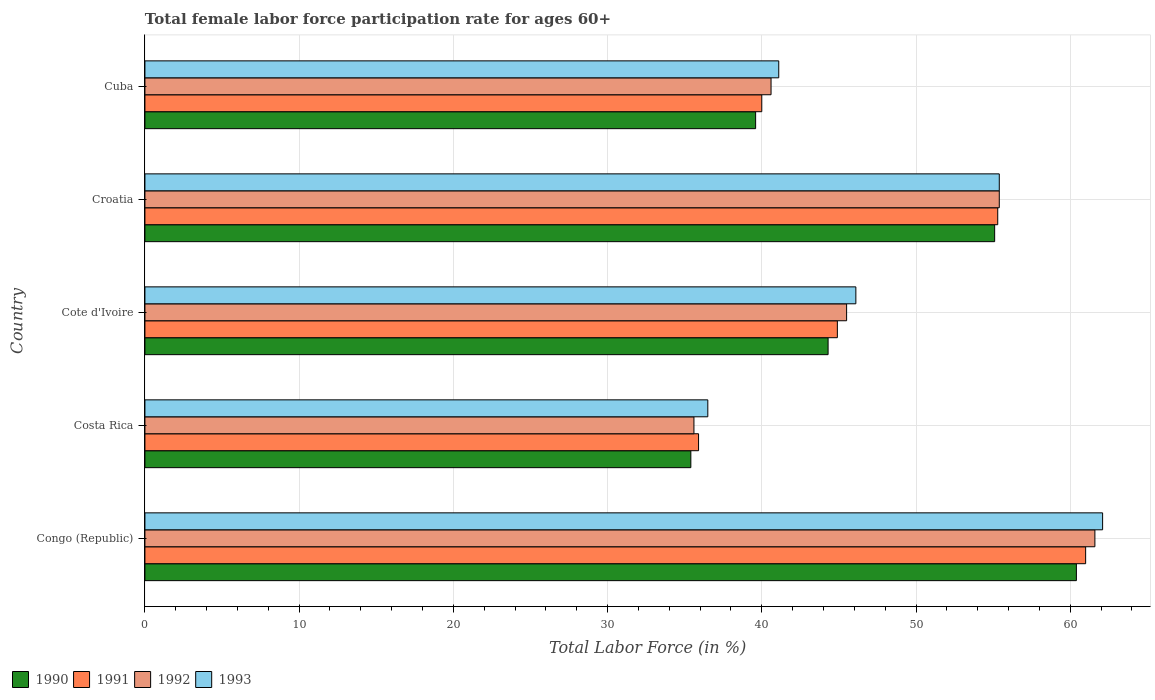How many different coloured bars are there?
Provide a succinct answer. 4. How many bars are there on the 5th tick from the bottom?
Ensure brevity in your answer.  4. What is the label of the 3rd group of bars from the top?
Make the answer very short. Cote d'Ivoire. In how many cases, is the number of bars for a given country not equal to the number of legend labels?
Make the answer very short. 0. What is the female labor force participation rate in 1993 in Croatia?
Provide a short and direct response. 55.4. Across all countries, what is the maximum female labor force participation rate in 1992?
Make the answer very short. 61.6. Across all countries, what is the minimum female labor force participation rate in 1990?
Keep it short and to the point. 35.4. In which country was the female labor force participation rate in 1993 maximum?
Make the answer very short. Congo (Republic). In which country was the female labor force participation rate in 1990 minimum?
Provide a short and direct response. Costa Rica. What is the total female labor force participation rate in 1990 in the graph?
Your response must be concise. 234.8. What is the difference between the female labor force participation rate in 1993 in Cote d'Ivoire and that in Cuba?
Give a very brief answer. 5. What is the difference between the female labor force participation rate in 1991 in Croatia and the female labor force participation rate in 1990 in Congo (Republic)?
Keep it short and to the point. -5.1. What is the average female labor force participation rate in 1990 per country?
Keep it short and to the point. 46.96. What is the difference between the female labor force participation rate in 1991 and female labor force participation rate in 1992 in Costa Rica?
Provide a short and direct response. 0.3. In how many countries, is the female labor force participation rate in 1991 greater than 8 %?
Give a very brief answer. 5. What is the ratio of the female labor force participation rate in 1993 in Congo (Republic) to that in Cuba?
Keep it short and to the point. 1.51. What is the difference between the highest and the second highest female labor force participation rate in 1993?
Keep it short and to the point. 6.7. In how many countries, is the female labor force participation rate in 1992 greater than the average female labor force participation rate in 1992 taken over all countries?
Provide a succinct answer. 2. Is the sum of the female labor force participation rate in 1991 in Croatia and Cuba greater than the maximum female labor force participation rate in 1993 across all countries?
Offer a very short reply. Yes. What does the 1st bar from the top in Costa Rica represents?
Make the answer very short. 1993. Is it the case that in every country, the sum of the female labor force participation rate in 1993 and female labor force participation rate in 1991 is greater than the female labor force participation rate in 1990?
Keep it short and to the point. Yes. How many countries are there in the graph?
Ensure brevity in your answer.  5. Does the graph contain any zero values?
Your answer should be very brief. No. Does the graph contain grids?
Offer a terse response. Yes. Where does the legend appear in the graph?
Give a very brief answer. Bottom left. How many legend labels are there?
Provide a short and direct response. 4. How are the legend labels stacked?
Provide a succinct answer. Horizontal. What is the title of the graph?
Provide a succinct answer. Total female labor force participation rate for ages 60+. Does "1979" appear as one of the legend labels in the graph?
Give a very brief answer. No. What is the label or title of the X-axis?
Provide a short and direct response. Total Labor Force (in %). What is the Total Labor Force (in %) of 1990 in Congo (Republic)?
Make the answer very short. 60.4. What is the Total Labor Force (in %) in 1992 in Congo (Republic)?
Offer a very short reply. 61.6. What is the Total Labor Force (in %) in 1993 in Congo (Republic)?
Ensure brevity in your answer.  62.1. What is the Total Labor Force (in %) of 1990 in Costa Rica?
Offer a very short reply. 35.4. What is the Total Labor Force (in %) of 1991 in Costa Rica?
Give a very brief answer. 35.9. What is the Total Labor Force (in %) of 1992 in Costa Rica?
Your answer should be very brief. 35.6. What is the Total Labor Force (in %) of 1993 in Costa Rica?
Keep it short and to the point. 36.5. What is the Total Labor Force (in %) in 1990 in Cote d'Ivoire?
Make the answer very short. 44.3. What is the Total Labor Force (in %) in 1991 in Cote d'Ivoire?
Ensure brevity in your answer.  44.9. What is the Total Labor Force (in %) in 1992 in Cote d'Ivoire?
Offer a very short reply. 45.5. What is the Total Labor Force (in %) in 1993 in Cote d'Ivoire?
Offer a terse response. 46.1. What is the Total Labor Force (in %) of 1990 in Croatia?
Ensure brevity in your answer.  55.1. What is the Total Labor Force (in %) of 1991 in Croatia?
Your answer should be very brief. 55.3. What is the Total Labor Force (in %) of 1992 in Croatia?
Provide a succinct answer. 55.4. What is the Total Labor Force (in %) of 1993 in Croatia?
Your answer should be very brief. 55.4. What is the Total Labor Force (in %) of 1990 in Cuba?
Ensure brevity in your answer.  39.6. What is the Total Labor Force (in %) of 1991 in Cuba?
Make the answer very short. 40. What is the Total Labor Force (in %) of 1992 in Cuba?
Ensure brevity in your answer.  40.6. What is the Total Labor Force (in %) in 1993 in Cuba?
Offer a very short reply. 41.1. Across all countries, what is the maximum Total Labor Force (in %) in 1990?
Provide a short and direct response. 60.4. Across all countries, what is the maximum Total Labor Force (in %) of 1992?
Your response must be concise. 61.6. Across all countries, what is the maximum Total Labor Force (in %) of 1993?
Your answer should be very brief. 62.1. Across all countries, what is the minimum Total Labor Force (in %) in 1990?
Offer a terse response. 35.4. Across all countries, what is the minimum Total Labor Force (in %) of 1991?
Give a very brief answer. 35.9. Across all countries, what is the minimum Total Labor Force (in %) in 1992?
Provide a succinct answer. 35.6. Across all countries, what is the minimum Total Labor Force (in %) in 1993?
Keep it short and to the point. 36.5. What is the total Total Labor Force (in %) of 1990 in the graph?
Ensure brevity in your answer.  234.8. What is the total Total Labor Force (in %) of 1991 in the graph?
Your answer should be compact. 237.1. What is the total Total Labor Force (in %) in 1992 in the graph?
Keep it short and to the point. 238.7. What is the total Total Labor Force (in %) of 1993 in the graph?
Make the answer very short. 241.2. What is the difference between the Total Labor Force (in %) of 1991 in Congo (Republic) and that in Costa Rica?
Make the answer very short. 25.1. What is the difference between the Total Labor Force (in %) in 1992 in Congo (Republic) and that in Costa Rica?
Make the answer very short. 26. What is the difference between the Total Labor Force (in %) of 1993 in Congo (Republic) and that in Costa Rica?
Offer a very short reply. 25.6. What is the difference between the Total Labor Force (in %) of 1990 in Congo (Republic) and that in Cote d'Ivoire?
Your answer should be compact. 16.1. What is the difference between the Total Labor Force (in %) in 1991 in Congo (Republic) and that in Cote d'Ivoire?
Keep it short and to the point. 16.1. What is the difference between the Total Labor Force (in %) of 1992 in Congo (Republic) and that in Cote d'Ivoire?
Keep it short and to the point. 16.1. What is the difference between the Total Labor Force (in %) in 1993 in Congo (Republic) and that in Cote d'Ivoire?
Make the answer very short. 16. What is the difference between the Total Labor Force (in %) in 1992 in Congo (Republic) and that in Croatia?
Give a very brief answer. 6.2. What is the difference between the Total Labor Force (in %) of 1990 in Congo (Republic) and that in Cuba?
Offer a terse response. 20.8. What is the difference between the Total Labor Force (in %) of 1991 in Congo (Republic) and that in Cuba?
Provide a succinct answer. 21. What is the difference between the Total Labor Force (in %) in 1991 in Costa Rica and that in Cote d'Ivoire?
Your answer should be compact. -9. What is the difference between the Total Labor Force (in %) in 1992 in Costa Rica and that in Cote d'Ivoire?
Ensure brevity in your answer.  -9.9. What is the difference between the Total Labor Force (in %) in 1993 in Costa Rica and that in Cote d'Ivoire?
Keep it short and to the point. -9.6. What is the difference between the Total Labor Force (in %) of 1990 in Costa Rica and that in Croatia?
Give a very brief answer. -19.7. What is the difference between the Total Labor Force (in %) of 1991 in Costa Rica and that in Croatia?
Your answer should be very brief. -19.4. What is the difference between the Total Labor Force (in %) of 1992 in Costa Rica and that in Croatia?
Your answer should be compact. -19.8. What is the difference between the Total Labor Force (in %) of 1993 in Costa Rica and that in Croatia?
Ensure brevity in your answer.  -18.9. What is the difference between the Total Labor Force (in %) in 1990 in Costa Rica and that in Cuba?
Provide a short and direct response. -4.2. What is the difference between the Total Labor Force (in %) in 1992 in Costa Rica and that in Cuba?
Give a very brief answer. -5. What is the difference between the Total Labor Force (in %) of 1991 in Cote d'Ivoire and that in Croatia?
Ensure brevity in your answer.  -10.4. What is the difference between the Total Labor Force (in %) of 1990 in Cote d'Ivoire and that in Cuba?
Make the answer very short. 4.7. What is the difference between the Total Labor Force (in %) in 1992 in Cote d'Ivoire and that in Cuba?
Provide a succinct answer. 4.9. What is the difference between the Total Labor Force (in %) in 1993 in Cote d'Ivoire and that in Cuba?
Make the answer very short. 5. What is the difference between the Total Labor Force (in %) in 1992 in Croatia and that in Cuba?
Make the answer very short. 14.8. What is the difference between the Total Labor Force (in %) of 1993 in Croatia and that in Cuba?
Offer a very short reply. 14.3. What is the difference between the Total Labor Force (in %) in 1990 in Congo (Republic) and the Total Labor Force (in %) in 1991 in Costa Rica?
Your response must be concise. 24.5. What is the difference between the Total Labor Force (in %) in 1990 in Congo (Republic) and the Total Labor Force (in %) in 1992 in Costa Rica?
Your response must be concise. 24.8. What is the difference between the Total Labor Force (in %) of 1990 in Congo (Republic) and the Total Labor Force (in %) of 1993 in Costa Rica?
Make the answer very short. 23.9. What is the difference between the Total Labor Force (in %) in 1991 in Congo (Republic) and the Total Labor Force (in %) in 1992 in Costa Rica?
Your response must be concise. 25.4. What is the difference between the Total Labor Force (in %) of 1992 in Congo (Republic) and the Total Labor Force (in %) of 1993 in Costa Rica?
Provide a short and direct response. 25.1. What is the difference between the Total Labor Force (in %) in 1990 in Congo (Republic) and the Total Labor Force (in %) in 1991 in Cote d'Ivoire?
Provide a short and direct response. 15.5. What is the difference between the Total Labor Force (in %) in 1990 in Congo (Republic) and the Total Labor Force (in %) in 1992 in Cote d'Ivoire?
Ensure brevity in your answer.  14.9. What is the difference between the Total Labor Force (in %) in 1990 in Congo (Republic) and the Total Labor Force (in %) in 1993 in Cote d'Ivoire?
Offer a terse response. 14.3. What is the difference between the Total Labor Force (in %) in 1991 in Congo (Republic) and the Total Labor Force (in %) in 1993 in Cote d'Ivoire?
Give a very brief answer. 14.9. What is the difference between the Total Labor Force (in %) of 1992 in Congo (Republic) and the Total Labor Force (in %) of 1993 in Cote d'Ivoire?
Provide a succinct answer. 15.5. What is the difference between the Total Labor Force (in %) of 1990 in Congo (Republic) and the Total Labor Force (in %) of 1992 in Croatia?
Make the answer very short. 5. What is the difference between the Total Labor Force (in %) in 1991 in Congo (Republic) and the Total Labor Force (in %) in 1992 in Croatia?
Provide a short and direct response. 5.6. What is the difference between the Total Labor Force (in %) of 1991 in Congo (Republic) and the Total Labor Force (in %) of 1993 in Croatia?
Give a very brief answer. 5.6. What is the difference between the Total Labor Force (in %) of 1990 in Congo (Republic) and the Total Labor Force (in %) of 1991 in Cuba?
Your answer should be compact. 20.4. What is the difference between the Total Labor Force (in %) of 1990 in Congo (Republic) and the Total Labor Force (in %) of 1992 in Cuba?
Provide a short and direct response. 19.8. What is the difference between the Total Labor Force (in %) in 1990 in Congo (Republic) and the Total Labor Force (in %) in 1993 in Cuba?
Make the answer very short. 19.3. What is the difference between the Total Labor Force (in %) in 1991 in Congo (Republic) and the Total Labor Force (in %) in 1992 in Cuba?
Make the answer very short. 20.4. What is the difference between the Total Labor Force (in %) of 1992 in Congo (Republic) and the Total Labor Force (in %) of 1993 in Cuba?
Your response must be concise. 20.5. What is the difference between the Total Labor Force (in %) of 1990 in Costa Rica and the Total Labor Force (in %) of 1991 in Cote d'Ivoire?
Keep it short and to the point. -9.5. What is the difference between the Total Labor Force (in %) of 1990 in Costa Rica and the Total Labor Force (in %) of 1992 in Cote d'Ivoire?
Your answer should be very brief. -10.1. What is the difference between the Total Labor Force (in %) of 1991 in Costa Rica and the Total Labor Force (in %) of 1992 in Cote d'Ivoire?
Your answer should be compact. -9.6. What is the difference between the Total Labor Force (in %) of 1990 in Costa Rica and the Total Labor Force (in %) of 1991 in Croatia?
Ensure brevity in your answer.  -19.9. What is the difference between the Total Labor Force (in %) of 1990 in Costa Rica and the Total Labor Force (in %) of 1992 in Croatia?
Make the answer very short. -20. What is the difference between the Total Labor Force (in %) of 1990 in Costa Rica and the Total Labor Force (in %) of 1993 in Croatia?
Offer a terse response. -20. What is the difference between the Total Labor Force (in %) in 1991 in Costa Rica and the Total Labor Force (in %) in 1992 in Croatia?
Your answer should be compact. -19.5. What is the difference between the Total Labor Force (in %) in 1991 in Costa Rica and the Total Labor Force (in %) in 1993 in Croatia?
Give a very brief answer. -19.5. What is the difference between the Total Labor Force (in %) of 1992 in Costa Rica and the Total Labor Force (in %) of 1993 in Croatia?
Offer a very short reply. -19.8. What is the difference between the Total Labor Force (in %) in 1990 in Costa Rica and the Total Labor Force (in %) in 1991 in Cuba?
Offer a very short reply. -4.6. What is the difference between the Total Labor Force (in %) in 1990 in Costa Rica and the Total Labor Force (in %) in 1993 in Cuba?
Your answer should be compact. -5.7. What is the difference between the Total Labor Force (in %) of 1991 in Costa Rica and the Total Labor Force (in %) of 1992 in Cuba?
Provide a short and direct response. -4.7. What is the difference between the Total Labor Force (in %) of 1991 in Costa Rica and the Total Labor Force (in %) of 1993 in Cuba?
Your answer should be very brief. -5.2. What is the difference between the Total Labor Force (in %) in 1992 in Costa Rica and the Total Labor Force (in %) in 1993 in Cuba?
Your response must be concise. -5.5. What is the difference between the Total Labor Force (in %) in 1990 in Cote d'Ivoire and the Total Labor Force (in %) in 1991 in Cuba?
Provide a succinct answer. 4.3. What is the difference between the Total Labor Force (in %) of 1990 in Cote d'Ivoire and the Total Labor Force (in %) of 1993 in Cuba?
Give a very brief answer. 3.2. What is the difference between the Total Labor Force (in %) in 1991 in Cote d'Ivoire and the Total Labor Force (in %) in 1992 in Cuba?
Keep it short and to the point. 4.3. What is the difference between the Total Labor Force (in %) of 1992 in Cote d'Ivoire and the Total Labor Force (in %) of 1993 in Cuba?
Provide a succinct answer. 4.4. What is the difference between the Total Labor Force (in %) of 1990 in Croatia and the Total Labor Force (in %) of 1993 in Cuba?
Your answer should be compact. 14. What is the difference between the Total Labor Force (in %) of 1991 in Croatia and the Total Labor Force (in %) of 1993 in Cuba?
Provide a succinct answer. 14.2. What is the difference between the Total Labor Force (in %) in 1992 in Croatia and the Total Labor Force (in %) in 1993 in Cuba?
Offer a very short reply. 14.3. What is the average Total Labor Force (in %) in 1990 per country?
Provide a short and direct response. 46.96. What is the average Total Labor Force (in %) in 1991 per country?
Your answer should be compact. 47.42. What is the average Total Labor Force (in %) in 1992 per country?
Your answer should be compact. 47.74. What is the average Total Labor Force (in %) of 1993 per country?
Your answer should be very brief. 48.24. What is the difference between the Total Labor Force (in %) in 1990 and Total Labor Force (in %) in 1992 in Congo (Republic)?
Make the answer very short. -1.2. What is the difference between the Total Labor Force (in %) of 1990 and Total Labor Force (in %) of 1993 in Congo (Republic)?
Offer a terse response. -1.7. What is the difference between the Total Labor Force (in %) of 1991 and Total Labor Force (in %) of 1992 in Congo (Republic)?
Provide a succinct answer. -0.6. What is the difference between the Total Labor Force (in %) of 1992 and Total Labor Force (in %) of 1993 in Congo (Republic)?
Offer a terse response. -0.5. What is the difference between the Total Labor Force (in %) of 1990 and Total Labor Force (in %) of 1991 in Costa Rica?
Give a very brief answer. -0.5. What is the difference between the Total Labor Force (in %) of 1990 and Total Labor Force (in %) of 1993 in Cote d'Ivoire?
Your answer should be compact. -1.8. What is the difference between the Total Labor Force (in %) of 1991 and Total Labor Force (in %) of 1992 in Cote d'Ivoire?
Provide a short and direct response. -0.6. What is the difference between the Total Labor Force (in %) in 1991 and Total Labor Force (in %) in 1992 in Croatia?
Offer a terse response. -0.1. What is the difference between the Total Labor Force (in %) of 1992 and Total Labor Force (in %) of 1993 in Croatia?
Keep it short and to the point. 0. What is the difference between the Total Labor Force (in %) of 1991 and Total Labor Force (in %) of 1993 in Cuba?
Keep it short and to the point. -1.1. What is the difference between the Total Labor Force (in %) in 1992 and Total Labor Force (in %) in 1993 in Cuba?
Offer a terse response. -0.5. What is the ratio of the Total Labor Force (in %) of 1990 in Congo (Republic) to that in Costa Rica?
Ensure brevity in your answer.  1.71. What is the ratio of the Total Labor Force (in %) in 1991 in Congo (Republic) to that in Costa Rica?
Make the answer very short. 1.7. What is the ratio of the Total Labor Force (in %) of 1992 in Congo (Republic) to that in Costa Rica?
Ensure brevity in your answer.  1.73. What is the ratio of the Total Labor Force (in %) in 1993 in Congo (Republic) to that in Costa Rica?
Provide a succinct answer. 1.7. What is the ratio of the Total Labor Force (in %) of 1990 in Congo (Republic) to that in Cote d'Ivoire?
Your answer should be very brief. 1.36. What is the ratio of the Total Labor Force (in %) of 1991 in Congo (Republic) to that in Cote d'Ivoire?
Give a very brief answer. 1.36. What is the ratio of the Total Labor Force (in %) of 1992 in Congo (Republic) to that in Cote d'Ivoire?
Your response must be concise. 1.35. What is the ratio of the Total Labor Force (in %) of 1993 in Congo (Republic) to that in Cote d'Ivoire?
Make the answer very short. 1.35. What is the ratio of the Total Labor Force (in %) in 1990 in Congo (Republic) to that in Croatia?
Keep it short and to the point. 1.1. What is the ratio of the Total Labor Force (in %) of 1991 in Congo (Republic) to that in Croatia?
Your response must be concise. 1.1. What is the ratio of the Total Labor Force (in %) of 1992 in Congo (Republic) to that in Croatia?
Provide a short and direct response. 1.11. What is the ratio of the Total Labor Force (in %) in 1993 in Congo (Republic) to that in Croatia?
Your answer should be compact. 1.12. What is the ratio of the Total Labor Force (in %) of 1990 in Congo (Republic) to that in Cuba?
Your response must be concise. 1.53. What is the ratio of the Total Labor Force (in %) in 1991 in Congo (Republic) to that in Cuba?
Provide a short and direct response. 1.52. What is the ratio of the Total Labor Force (in %) of 1992 in Congo (Republic) to that in Cuba?
Provide a short and direct response. 1.52. What is the ratio of the Total Labor Force (in %) in 1993 in Congo (Republic) to that in Cuba?
Your answer should be very brief. 1.51. What is the ratio of the Total Labor Force (in %) in 1990 in Costa Rica to that in Cote d'Ivoire?
Make the answer very short. 0.8. What is the ratio of the Total Labor Force (in %) in 1991 in Costa Rica to that in Cote d'Ivoire?
Give a very brief answer. 0.8. What is the ratio of the Total Labor Force (in %) of 1992 in Costa Rica to that in Cote d'Ivoire?
Offer a terse response. 0.78. What is the ratio of the Total Labor Force (in %) of 1993 in Costa Rica to that in Cote d'Ivoire?
Offer a very short reply. 0.79. What is the ratio of the Total Labor Force (in %) in 1990 in Costa Rica to that in Croatia?
Provide a short and direct response. 0.64. What is the ratio of the Total Labor Force (in %) of 1991 in Costa Rica to that in Croatia?
Provide a short and direct response. 0.65. What is the ratio of the Total Labor Force (in %) in 1992 in Costa Rica to that in Croatia?
Ensure brevity in your answer.  0.64. What is the ratio of the Total Labor Force (in %) in 1993 in Costa Rica to that in Croatia?
Make the answer very short. 0.66. What is the ratio of the Total Labor Force (in %) of 1990 in Costa Rica to that in Cuba?
Offer a very short reply. 0.89. What is the ratio of the Total Labor Force (in %) of 1991 in Costa Rica to that in Cuba?
Provide a succinct answer. 0.9. What is the ratio of the Total Labor Force (in %) of 1992 in Costa Rica to that in Cuba?
Give a very brief answer. 0.88. What is the ratio of the Total Labor Force (in %) in 1993 in Costa Rica to that in Cuba?
Your answer should be very brief. 0.89. What is the ratio of the Total Labor Force (in %) in 1990 in Cote d'Ivoire to that in Croatia?
Offer a very short reply. 0.8. What is the ratio of the Total Labor Force (in %) of 1991 in Cote d'Ivoire to that in Croatia?
Offer a terse response. 0.81. What is the ratio of the Total Labor Force (in %) of 1992 in Cote d'Ivoire to that in Croatia?
Offer a terse response. 0.82. What is the ratio of the Total Labor Force (in %) in 1993 in Cote d'Ivoire to that in Croatia?
Keep it short and to the point. 0.83. What is the ratio of the Total Labor Force (in %) of 1990 in Cote d'Ivoire to that in Cuba?
Keep it short and to the point. 1.12. What is the ratio of the Total Labor Force (in %) of 1991 in Cote d'Ivoire to that in Cuba?
Provide a short and direct response. 1.12. What is the ratio of the Total Labor Force (in %) in 1992 in Cote d'Ivoire to that in Cuba?
Offer a very short reply. 1.12. What is the ratio of the Total Labor Force (in %) in 1993 in Cote d'Ivoire to that in Cuba?
Give a very brief answer. 1.12. What is the ratio of the Total Labor Force (in %) in 1990 in Croatia to that in Cuba?
Offer a very short reply. 1.39. What is the ratio of the Total Labor Force (in %) of 1991 in Croatia to that in Cuba?
Provide a succinct answer. 1.38. What is the ratio of the Total Labor Force (in %) in 1992 in Croatia to that in Cuba?
Your response must be concise. 1.36. What is the ratio of the Total Labor Force (in %) in 1993 in Croatia to that in Cuba?
Provide a succinct answer. 1.35. What is the difference between the highest and the second highest Total Labor Force (in %) of 1990?
Your response must be concise. 5.3. What is the difference between the highest and the second highest Total Labor Force (in %) of 1991?
Provide a short and direct response. 5.7. What is the difference between the highest and the lowest Total Labor Force (in %) in 1991?
Your response must be concise. 25.1. What is the difference between the highest and the lowest Total Labor Force (in %) in 1992?
Offer a terse response. 26. What is the difference between the highest and the lowest Total Labor Force (in %) of 1993?
Make the answer very short. 25.6. 